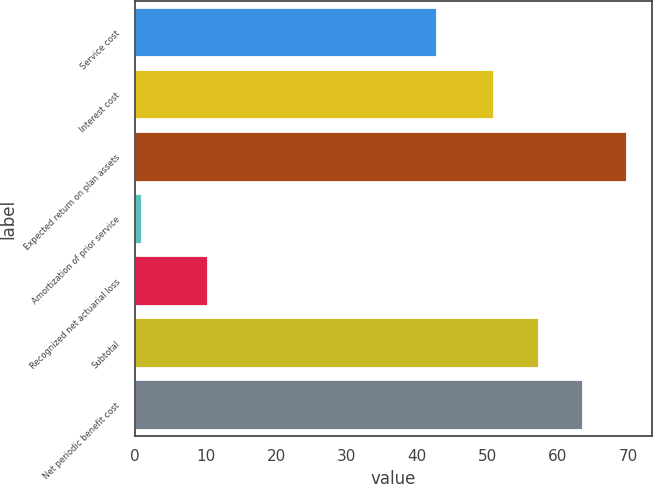<chart> <loc_0><loc_0><loc_500><loc_500><bar_chart><fcel>Service cost<fcel>Interest cost<fcel>Expected return on plan assets<fcel>Amortization of prior service<fcel>Recognized net actuarial loss<fcel>Subtotal<fcel>Net periodic benefit cost<nl><fcel>42.8<fcel>51<fcel>69.9<fcel>1<fcel>10.3<fcel>57.3<fcel>63.6<nl></chart> 